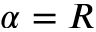<formula> <loc_0><loc_0><loc_500><loc_500>\alpha = R</formula> 